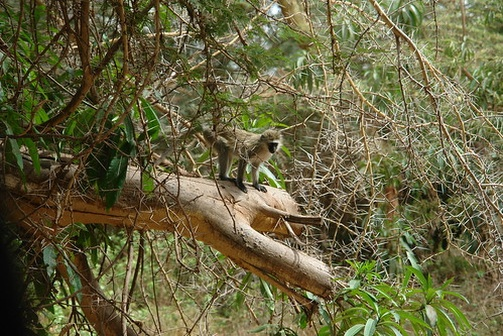Can you describe what the monkey might be thinking or feeling? The monkey perched on the branch appears to be in an observant and curious state. Its keen gaze towards the camera suggests that it might be intrigued by its surroundings or perhaps the presence of the photographer. It could be feeling a mixture of curiosity and alertness, ready to react to any new developments in its environment. The lush, green setting provides it with a sense of security, as it clings comfortably to the branch, blending into its natural habitat. 